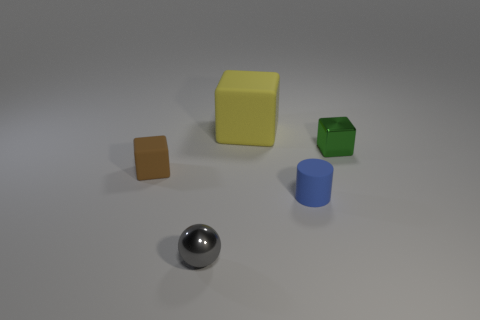Do the small shiny thing right of the small gray ball and the tiny gray metal thing have the same shape? no 